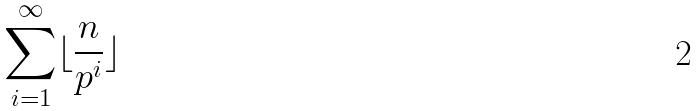<formula> <loc_0><loc_0><loc_500><loc_500>\sum _ { i = 1 } ^ { \infty } \lfloor \frac { n } { p ^ { i } } \rfloor</formula> 